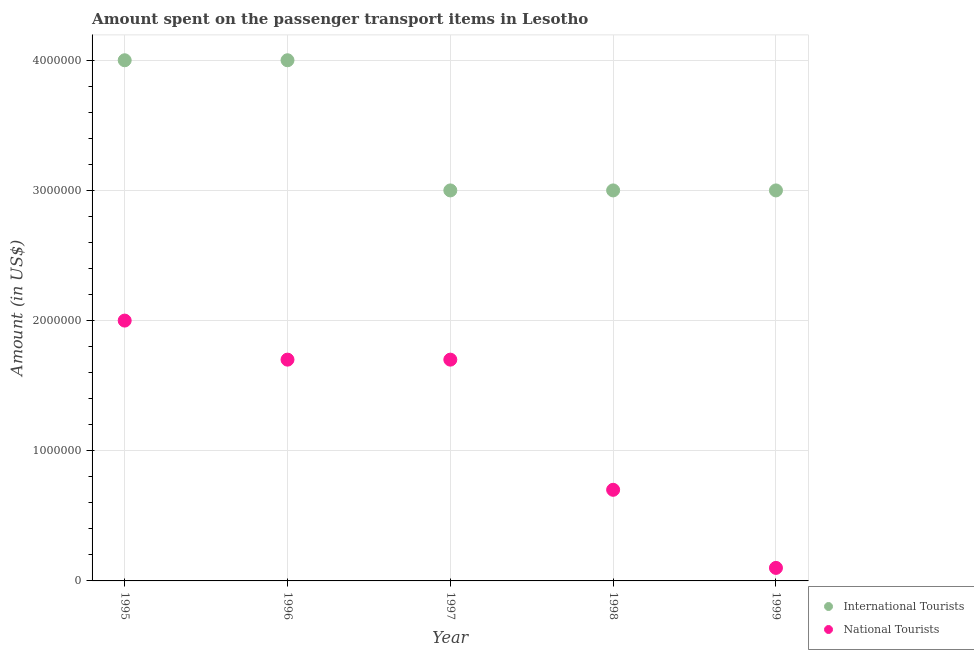How many different coloured dotlines are there?
Give a very brief answer. 2. Is the number of dotlines equal to the number of legend labels?
Offer a very short reply. Yes. What is the amount spent on transport items of international tourists in 1996?
Ensure brevity in your answer.  4.00e+06. Across all years, what is the maximum amount spent on transport items of national tourists?
Provide a succinct answer. 2.00e+06. Across all years, what is the minimum amount spent on transport items of international tourists?
Give a very brief answer. 3.00e+06. In which year was the amount spent on transport items of national tourists maximum?
Provide a succinct answer. 1995. In which year was the amount spent on transport items of national tourists minimum?
Your answer should be compact. 1999. What is the total amount spent on transport items of international tourists in the graph?
Provide a short and direct response. 1.70e+07. What is the difference between the amount spent on transport items of national tourists in 1995 and that in 1998?
Your answer should be compact. 1.30e+06. What is the difference between the amount spent on transport items of national tourists in 1999 and the amount spent on transport items of international tourists in 1996?
Your answer should be compact. -3.90e+06. What is the average amount spent on transport items of international tourists per year?
Your response must be concise. 3.40e+06. In the year 1998, what is the difference between the amount spent on transport items of national tourists and amount spent on transport items of international tourists?
Offer a terse response. -2.30e+06. What is the ratio of the amount spent on transport items of international tourists in 1998 to that in 1999?
Provide a succinct answer. 1. Is the difference between the amount spent on transport items of national tourists in 1995 and 1999 greater than the difference between the amount spent on transport items of international tourists in 1995 and 1999?
Your response must be concise. Yes. What is the difference between the highest and the second highest amount spent on transport items of national tourists?
Provide a succinct answer. 3.00e+05. What is the difference between the highest and the lowest amount spent on transport items of national tourists?
Provide a short and direct response. 1.90e+06. Is the sum of the amount spent on transport items of international tourists in 1997 and 1998 greater than the maximum amount spent on transport items of national tourists across all years?
Your answer should be very brief. Yes. Is the amount spent on transport items of national tourists strictly less than the amount spent on transport items of international tourists over the years?
Offer a very short reply. Yes. How many dotlines are there?
Keep it short and to the point. 2. How many years are there in the graph?
Provide a succinct answer. 5. Does the graph contain any zero values?
Provide a short and direct response. No. Does the graph contain grids?
Keep it short and to the point. Yes. What is the title of the graph?
Provide a succinct answer. Amount spent on the passenger transport items in Lesotho. Does "Under-5(female)" appear as one of the legend labels in the graph?
Your answer should be very brief. No. What is the Amount (in US$) of National Tourists in 1995?
Give a very brief answer. 2.00e+06. What is the Amount (in US$) of International Tourists in 1996?
Keep it short and to the point. 4.00e+06. What is the Amount (in US$) of National Tourists in 1996?
Ensure brevity in your answer.  1.70e+06. What is the Amount (in US$) in National Tourists in 1997?
Your answer should be very brief. 1.70e+06. What is the Amount (in US$) in International Tourists in 1998?
Offer a terse response. 3.00e+06. What is the Amount (in US$) in International Tourists in 1999?
Keep it short and to the point. 3.00e+06. Across all years, what is the maximum Amount (in US$) in International Tourists?
Give a very brief answer. 4.00e+06. Across all years, what is the maximum Amount (in US$) in National Tourists?
Ensure brevity in your answer.  2.00e+06. What is the total Amount (in US$) of International Tourists in the graph?
Your answer should be very brief. 1.70e+07. What is the total Amount (in US$) in National Tourists in the graph?
Your response must be concise. 6.20e+06. What is the difference between the Amount (in US$) of International Tourists in 1995 and that in 1996?
Your answer should be compact. 0. What is the difference between the Amount (in US$) of International Tourists in 1995 and that in 1997?
Your answer should be very brief. 1.00e+06. What is the difference between the Amount (in US$) of National Tourists in 1995 and that in 1997?
Provide a succinct answer. 3.00e+05. What is the difference between the Amount (in US$) in International Tourists in 1995 and that in 1998?
Offer a very short reply. 1.00e+06. What is the difference between the Amount (in US$) in National Tourists in 1995 and that in 1998?
Your answer should be very brief. 1.30e+06. What is the difference between the Amount (in US$) of National Tourists in 1995 and that in 1999?
Keep it short and to the point. 1.90e+06. What is the difference between the Amount (in US$) of International Tourists in 1996 and that in 1997?
Your answer should be very brief. 1.00e+06. What is the difference between the Amount (in US$) in National Tourists in 1996 and that in 1997?
Keep it short and to the point. 0. What is the difference between the Amount (in US$) in National Tourists in 1996 and that in 1998?
Ensure brevity in your answer.  1.00e+06. What is the difference between the Amount (in US$) in International Tourists in 1996 and that in 1999?
Ensure brevity in your answer.  1.00e+06. What is the difference between the Amount (in US$) of National Tourists in 1996 and that in 1999?
Your answer should be very brief. 1.60e+06. What is the difference between the Amount (in US$) of National Tourists in 1997 and that in 1998?
Keep it short and to the point. 1.00e+06. What is the difference between the Amount (in US$) in National Tourists in 1997 and that in 1999?
Offer a very short reply. 1.60e+06. What is the difference between the Amount (in US$) in National Tourists in 1998 and that in 1999?
Keep it short and to the point. 6.00e+05. What is the difference between the Amount (in US$) of International Tourists in 1995 and the Amount (in US$) of National Tourists in 1996?
Ensure brevity in your answer.  2.30e+06. What is the difference between the Amount (in US$) of International Tourists in 1995 and the Amount (in US$) of National Tourists in 1997?
Ensure brevity in your answer.  2.30e+06. What is the difference between the Amount (in US$) of International Tourists in 1995 and the Amount (in US$) of National Tourists in 1998?
Provide a short and direct response. 3.30e+06. What is the difference between the Amount (in US$) of International Tourists in 1995 and the Amount (in US$) of National Tourists in 1999?
Provide a succinct answer. 3.90e+06. What is the difference between the Amount (in US$) of International Tourists in 1996 and the Amount (in US$) of National Tourists in 1997?
Provide a succinct answer. 2.30e+06. What is the difference between the Amount (in US$) of International Tourists in 1996 and the Amount (in US$) of National Tourists in 1998?
Your answer should be very brief. 3.30e+06. What is the difference between the Amount (in US$) in International Tourists in 1996 and the Amount (in US$) in National Tourists in 1999?
Keep it short and to the point. 3.90e+06. What is the difference between the Amount (in US$) in International Tourists in 1997 and the Amount (in US$) in National Tourists in 1998?
Keep it short and to the point. 2.30e+06. What is the difference between the Amount (in US$) in International Tourists in 1997 and the Amount (in US$) in National Tourists in 1999?
Keep it short and to the point. 2.90e+06. What is the difference between the Amount (in US$) of International Tourists in 1998 and the Amount (in US$) of National Tourists in 1999?
Offer a terse response. 2.90e+06. What is the average Amount (in US$) in International Tourists per year?
Offer a very short reply. 3.40e+06. What is the average Amount (in US$) of National Tourists per year?
Offer a terse response. 1.24e+06. In the year 1995, what is the difference between the Amount (in US$) in International Tourists and Amount (in US$) in National Tourists?
Ensure brevity in your answer.  2.00e+06. In the year 1996, what is the difference between the Amount (in US$) of International Tourists and Amount (in US$) of National Tourists?
Your response must be concise. 2.30e+06. In the year 1997, what is the difference between the Amount (in US$) in International Tourists and Amount (in US$) in National Tourists?
Make the answer very short. 1.30e+06. In the year 1998, what is the difference between the Amount (in US$) in International Tourists and Amount (in US$) in National Tourists?
Your answer should be compact. 2.30e+06. In the year 1999, what is the difference between the Amount (in US$) of International Tourists and Amount (in US$) of National Tourists?
Give a very brief answer. 2.90e+06. What is the ratio of the Amount (in US$) in National Tourists in 1995 to that in 1996?
Your answer should be very brief. 1.18. What is the ratio of the Amount (in US$) in International Tourists in 1995 to that in 1997?
Offer a very short reply. 1.33. What is the ratio of the Amount (in US$) in National Tourists in 1995 to that in 1997?
Your response must be concise. 1.18. What is the ratio of the Amount (in US$) of International Tourists in 1995 to that in 1998?
Your response must be concise. 1.33. What is the ratio of the Amount (in US$) of National Tourists in 1995 to that in 1998?
Give a very brief answer. 2.86. What is the ratio of the Amount (in US$) of International Tourists in 1995 to that in 1999?
Give a very brief answer. 1.33. What is the ratio of the Amount (in US$) in National Tourists in 1995 to that in 1999?
Ensure brevity in your answer.  20. What is the ratio of the Amount (in US$) of National Tourists in 1996 to that in 1998?
Offer a terse response. 2.43. What is the ratio of the Amount (in US$) of National Tourists in 1996 to that in 1999?
Give a very brief answer. 17. What is the ratio of the Amount (in US$) in International Tourists in 1997 to that in 1998?
Ensure brevity in your answer.  1. What is the ratio of the Amount (in US$) of National Tourists in 1997 to that in 1998?
Offer a terse response. 2.43. What is the ratio of the Amount (in US$) of International Tourists in 1997 to that in 1999?
Provide a short and direct response. 1. What is the ratio of the Amount (in US$) of National Tourists in 1997 to that in 1999?
Ensure brevity in your answer.  17. What is the ratio of the Amount (in US$) in National Tourists in 1998 to that in 1999?
Ensure brevity in your answer.  7. What is the difference between the highest and the lowest Amount (in US$) of National Tourists?
Provide a succinct answer. 1.90e+06. 